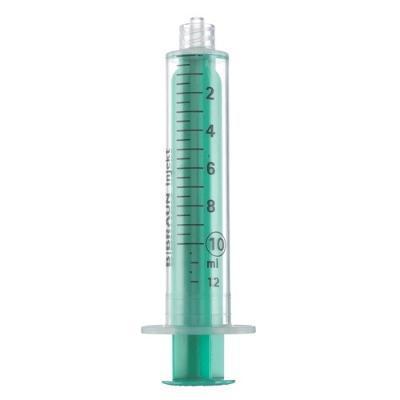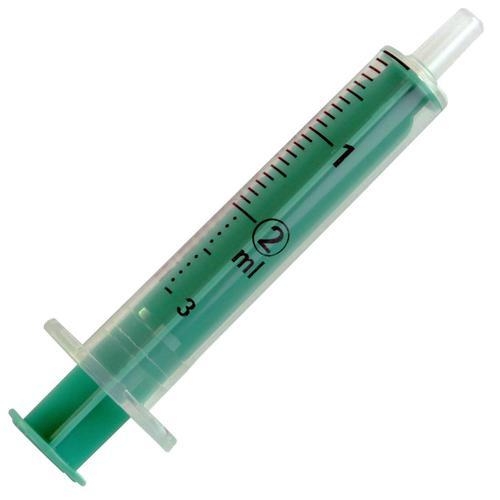The first image is the image on the left, the second image is the image on the right. Analyze the images presented: Is the assertion "There are the same amount of syringes in the image on the left as in the image on the right." valid? Answer yes or no. Yes. The first image is the image on the left, the second image is the image on the right. Examine the images to the left and right. Is the description "Right and left images contain the same number of syringe-type items." accurate? Answer yes or no. Yes. 